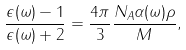<formula> <loc_0><loc_0><loc_500><loc_500>\frac { \epsilon ( \omega ) - 1 } { \epsilon ( \omega ) + 2 } = \frac { 4 \pi } { 3 } \frac { N _ { A } \alpha ( \omega ) \rho } { M } ,</formula> 